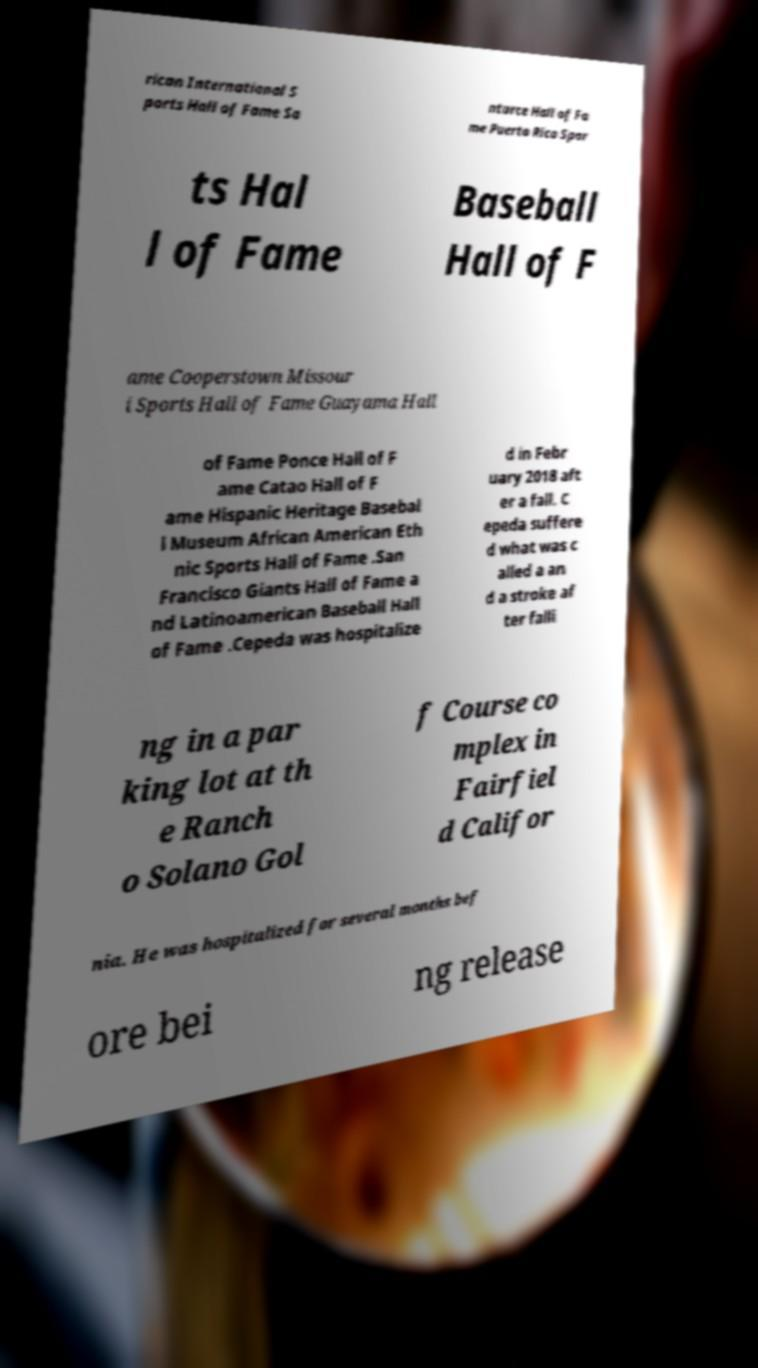Please read and relay the text visible in this image. What does it say? rican International S ports Hall of Fame Sa nturce Hall of Fa me Puerto Rico Spor ts Hal l of Fame Baseball Hall of F ame Cooperstown Missour i Sports Hall of Fame Guayama Hall of Fame Ponce Hall of F ame Catao Hall of F ame Hispanic Heritage Basebal l Museum African American Eth nic Sports Hall of Fame .San Francisco Giants Hall of Fame a nd Latinoamerican Baseball Hall of Fame .Cepeda was hospitalize d in Febr uary 2018 aft er a fall. C epeda suffere d what was c alled a an d a stroke af ter falli ng in a par king lot at th e Ranch o Solano Gol f Course co mplex in Fairfiel d Califor nia. He was hospitalized for several months bef ore bei ng release 